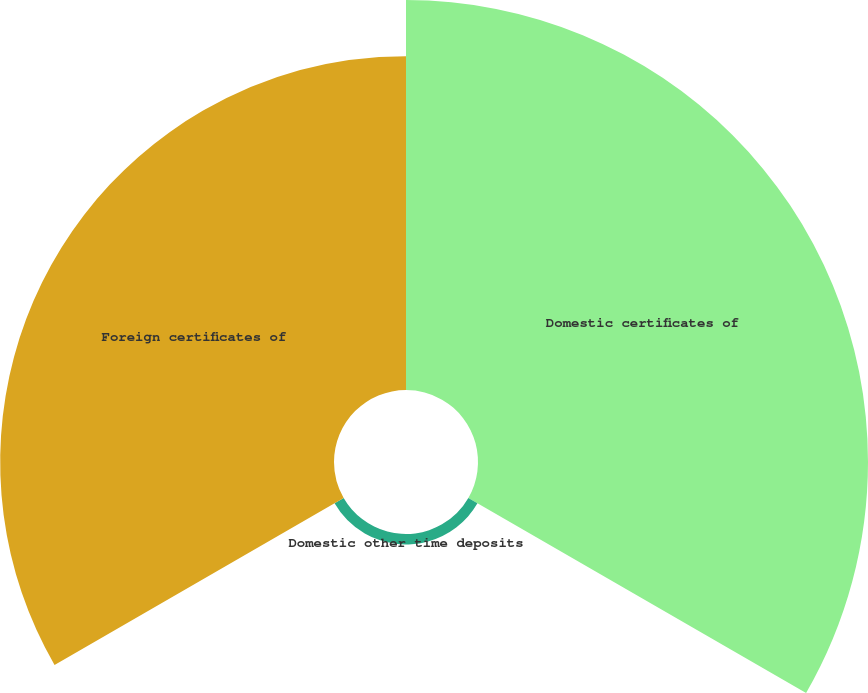<chart> <loc_0><loc_0><loc_500><loc_500><pie_chart><fcel>Domestic certificates of<fcel>Domestic other time deposits<fcel>Foreign certificates of<nl><fcel>53.11%<fcel>1.43%<fcel>45.46%<nl></chart> 